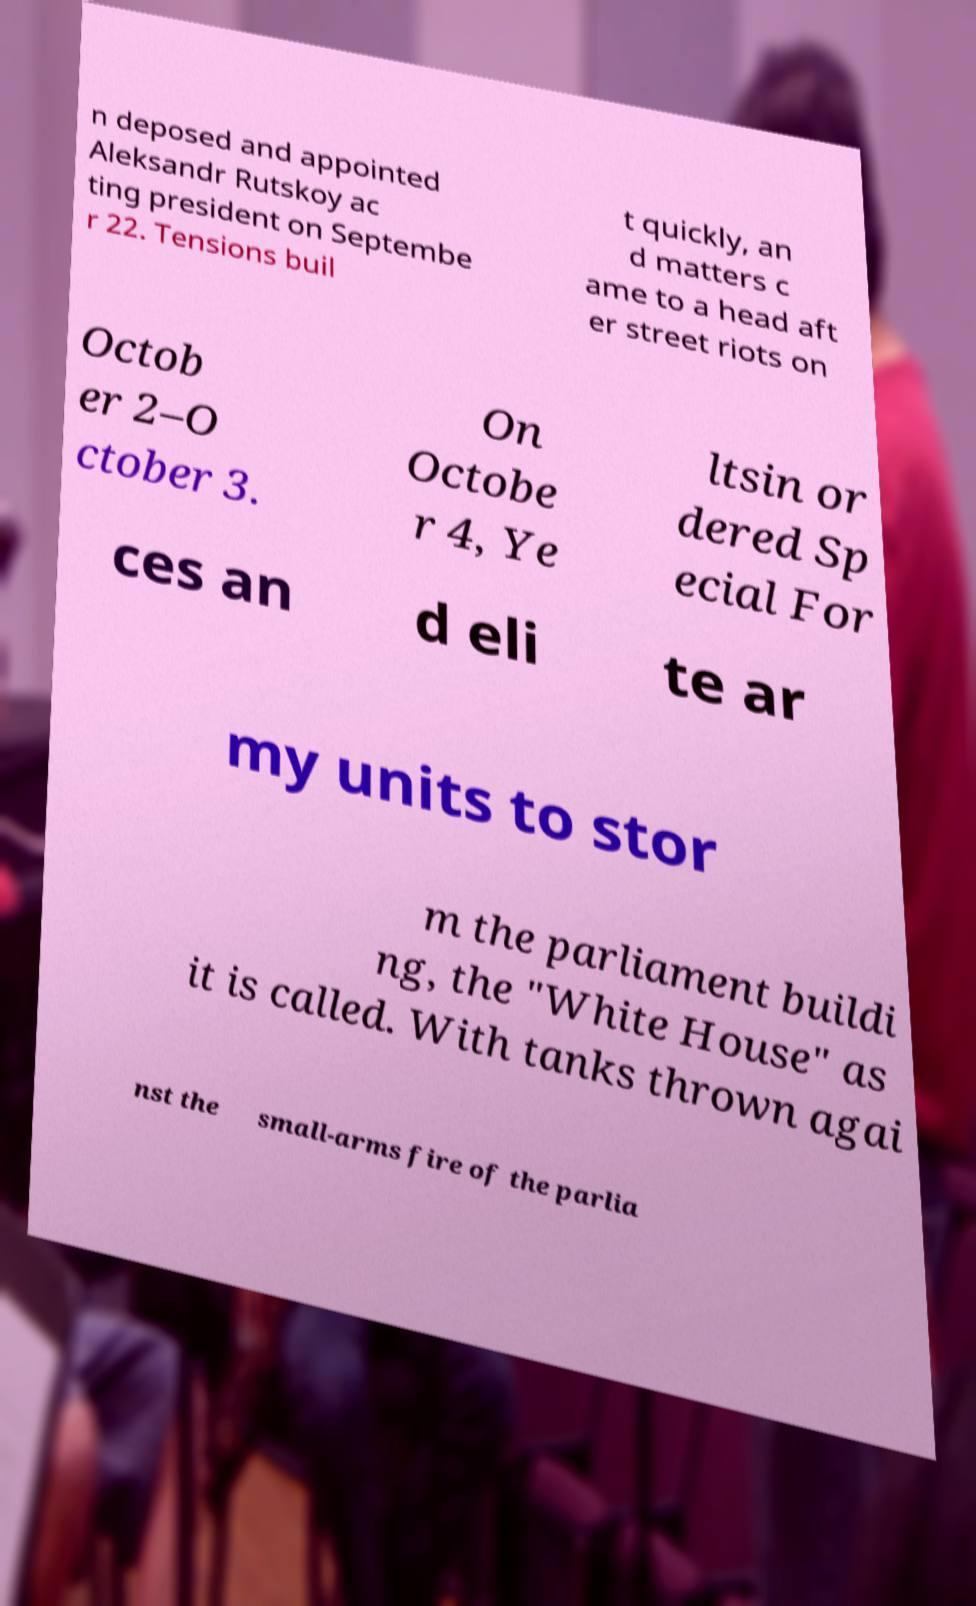Please read and relay the text visible in this image. What does it say? n deposed and appointed Aleksandr Rutskoy ac ting president on Septembe r 22. Tensions buil t quickly, an d matters c ame to a head aft er street riots on Octob er 2–O ctober 3. On Octobe r 4, Ye ltsin or dered Sp ecial For ces an d eli te ar my units to stor m the parliament buildi ng, the "White House" as it is called. With tanks thrown agai nst the small-arms fire of the parlia 